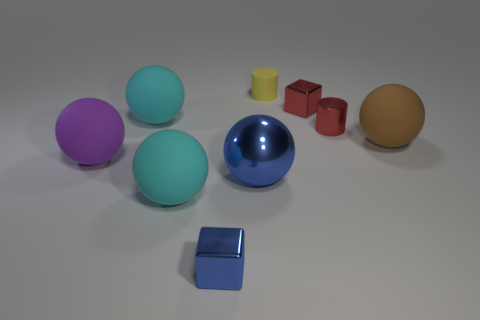What number of small things are the same color as the metal cylinder?
Your response must be concise. 1. There is a large blue thing to the left of the brown rubber object; is its shape the same as the purple object?
Give a very brief answer. Yes. Is the number of big blue metallic things that are on the right side of the yellow cylinder less than the number of cyan balls that are behind the brown rubber sphere?
Your response must be concise. Yes. There is a blue cube that is in front of the metal cylinder; what material is it?
Make the answer very short. Metal. The cube that is the same color as the big metal ball is what size?
Ensure brevity in your answer.  Small. Is there a red metallic block that has the same size as the purple rubber ball?
Make the answer very short. No. There is a big brown object; is its shape the same as the large cyan matte object in front of the blue ball?
Offer a terse response. Yes. There is a red thing behind the shiny cylinder; is it the same size as the cylinder that is left of the red metal cylinder?
Keep it short and to the point. Yes. What number of other things are the same shape as the large blue shiny thing?
Your response must be concise. 4. The big ball to the left of the large ball behind the brown matte sphere is made of what material?
Your answer should be very brief. Rubber. 